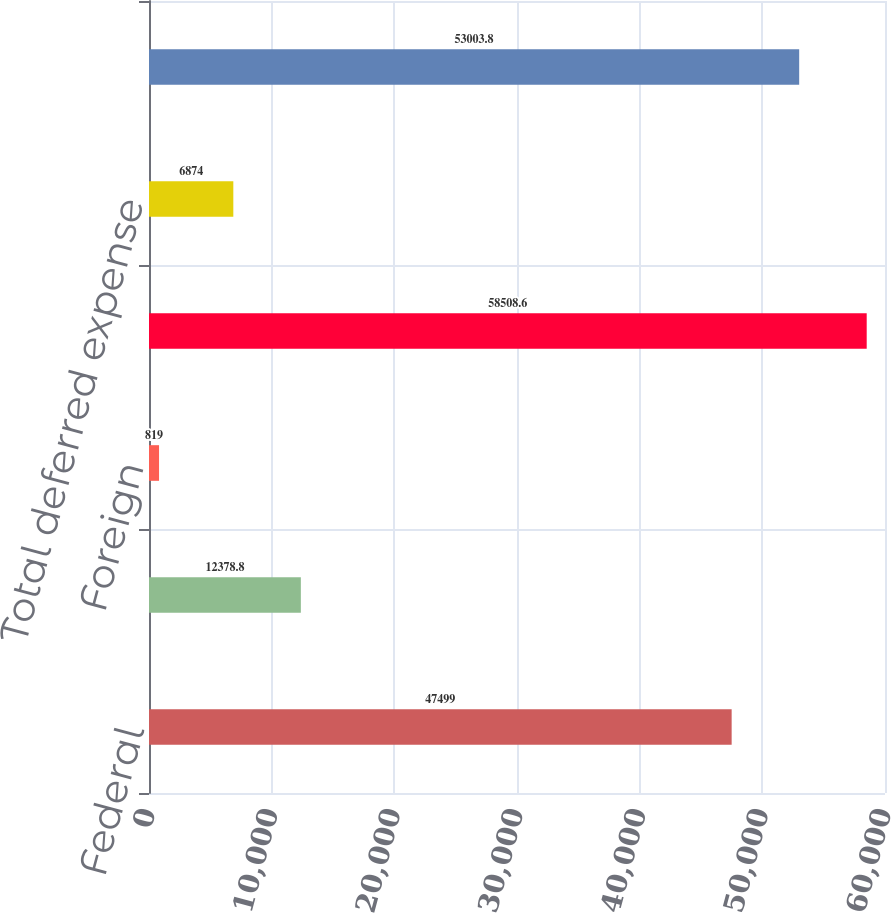<chart> <loc_0><loc_0><loc_500><loc_500><bar_chart><fcel>Federal<fcel>State<fcel>Foreign<fcel>Total current expense<fcel>Total deferred expense<fcel>Total income tax expense<nl><fcel>47499<fcel>12378.8<fcel>819<fcel>58508.6<fcel>6874<fcel>53003.8<nl></chart> 